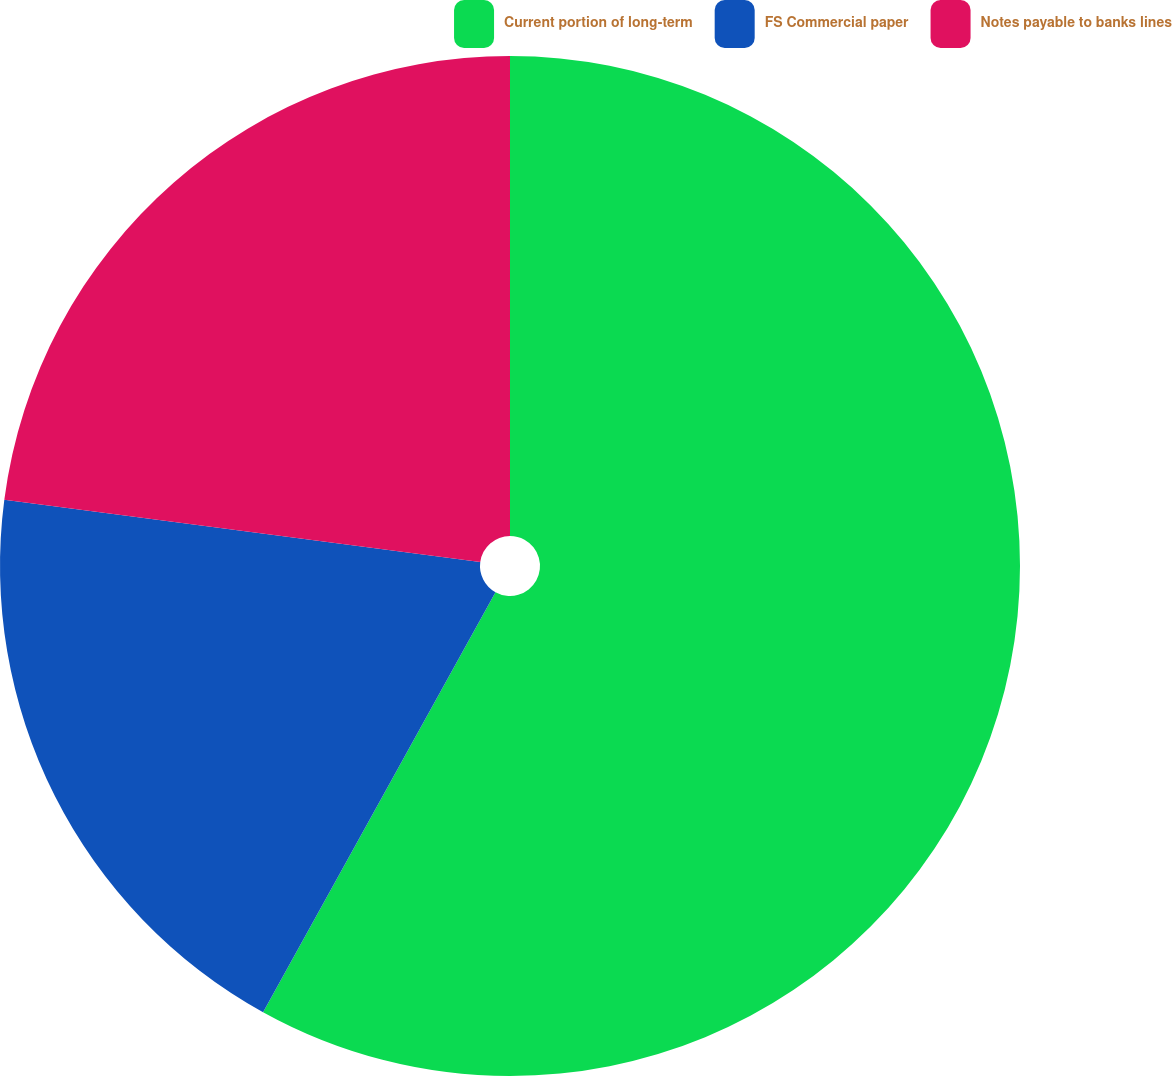Convert chart to OTSL. <chart><loc_0><loc_0><loc_500><loc_500><pie_chart><fcel>Current portion of long-term<fcel>FS Commercial paper<fcel>Notes payable to banks lines<nl><fcel>58.05%<fcel>19.03%<fcel>22.93%<nl></chart> 